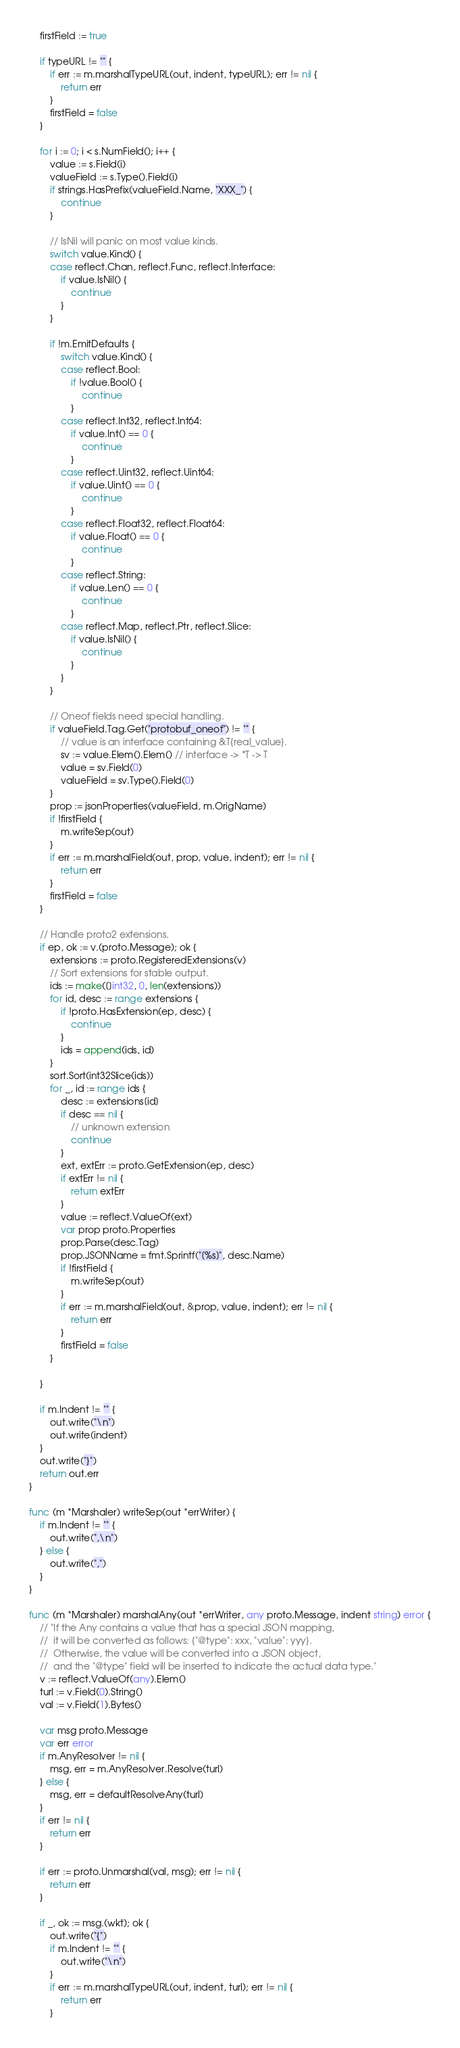<code> <loc_0><loc_0><loc_500><loc_500><_Go_>	firstField := true

	if typeURL != "" {
		if err := m.marshalTypeURL(out, indent, typeURL); err != nil {
			return err
		}
		firstField = false
	}

	for i := 0; i < s.NumField(); i++ {
		value := s.Field(i)
		valueField := s.Type().Field(i)
		if strings.HasPrefix(valueField.Name, "XXX_") {
			continue
		}

		// IsNil will panic on most value kinds.
		switch value.Kind() {
		case reflect.Chan, reflect.Func, reflect.Interface:
			if value.IsNil() {
				continue
			}
		}

		if !m.EmitDefaults {
			switch value.Kind() {
			case reflect.Bool:
				if !value.Bool() {
					continue
				}
			case reflect.Int32, reflect.Int64:
				if value.Int() == 0 {
					continue
				}
			case reflect.Uint32, reflect.Uint64:
				if value.Uint() == 0 {
					continue
				}
			case reflect.Float32, reflect.Float64:
				if value.Float() == 0 {
					continue
				}
			case reflect.String:
				if value.Len() == 0 {
					continue
				}
			case reflect.Map, reflect.Ptr, reflect.Slice:
				if value.IsNil() {
					continue
				}
			}
		}

		// Oneof fields need special handling.
		if valueField.Tag.Get("protobuf_oneof") != "" {
			// value is an interface containing &T{real_value}.
			sv := value.Elem().Elem() // interface -> *T -> T
			value = sv.Field(0)
			valueField = sv.Type().Field(0)
		}
		prop := jsonProperties(valueField, m.OrigName)
		if !firstField {
			m.writeSep(out)
		}
		if err := m.marshalField(out, prop, value, indent); err != nil {
			return err
		}
		firstField = false
	}

	// Handle proto2 extensions.
	if ep, ok := v.(proto.Message); ok {
		extensions := proto.RegisteredExtensions(v)
		// Sort extensions for stable output.
		ids := make([]int32, 0, len(extensions))
		for id, desc := range extensions {
			if !proto.HasExtension(ep, desc) {
				continue
			}
			ids = append(ids, id)
		}
		sort.Sort(int32Slice(ids))
		for _, id := range ids {
			desc := extensions[id]
			if desc == nil {
				// unknown extension
				continue
			}
			ext, extErr := proto.GetExtension(ep, desc)
			if extErr != nil {
				return extErr
			}
			value := reflect.ValueOf(ext)
			var prop proto.Properties
			prop.Parse(desc.Tag)
			prop.JSONName = fmt.Sprintf("[%s]", desc.Name)
			if !firstField {
				m.writeSep(out)
			}
			if err := m.marshalField(out, &prop, value, indent); err != nil {
				return err
			}
			firstField = false
		}

	}

	if m.Indent != "" {
		out.write("\n")
		out.write(indent)
	}
	out.write("}")
	return out.err
}

func (m *Marshaler) writeSep(out *errWriter) {
	if m.Indent != "" {
		out.write(",\n")
	} else {
		out.write(",")
	}
}

func (m *Marshaler) marshalAny(out *errWriter, any proto.Message, indent string) error {
	// "If the Any contains a value that has a special JSON mapping,
	//  it will be converted as follows: {"@type": xxx, "value": yyy}.
	//  Otherwise, the value will be converted into a JSON object,
	//  and the "@type" field will be inserted to indicate the actual data type."
	v := reflect.ValueOf(any).Elem()
	turl := v.Field(0).String()
	val := v.Field(1).Bytes()

	var msg proto.Message
	var err error
	if m.AnyResolver != nil {
		msg, err = m.AnyResolver.Resolve(turl)
	} else {
		msg, err = defaultResolveAny(turl)
	}
	if err != nil {
		return err
	}

	if err := proto.Unmarshal(val, msg); err != nil {
		return err
	}

	if _, ok := msg.(wkt); ok {
		out.write("{")
		if m.Indent != "" {
			out.write("\n")
		}
		if err := m.marshalTypeURL(out, indent, turl); err != nil {
			return err
		}</code> 